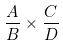Convert formula to latex. <formula><loc_0><loc_0><loc_500><loc_500>\frac { A } { B } \times \frac { C } { D }</formula> 